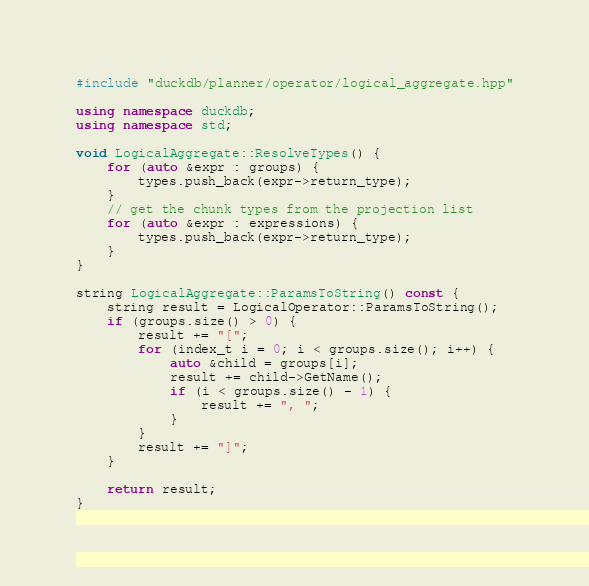Convert code to text. <code><loc_0><loc_0><loc_500><loc_500><_C++_>#include "duckdb/planner/operator/logical_aggregate.hpp"

using namespace duckdb;
using namespace std;

void LogicalAggregate::ResolveTypes() {
	for (auto &expr : groups) {
		types.push_back(expr->return_type);
	}
	// get the chunk types from the projection list
	for (auto &expr : expressions) {
		types.push_back(expr->return_type);
	}
}

string LogicalAggregate::ParamsToString() const {
	string result = LogicalOperator::ParamsToString();
	if (groups.size() > 0) {
		result += "[";
		for (index_t i = 0; i < groups.size(); i++) {
			auto &child = groups[i];
			result += child->GetName();
			if (i < groups.size() - 1) {
				result += ", ";
			}
		}
		result += "]";
	}

	return result;
}
</code> 